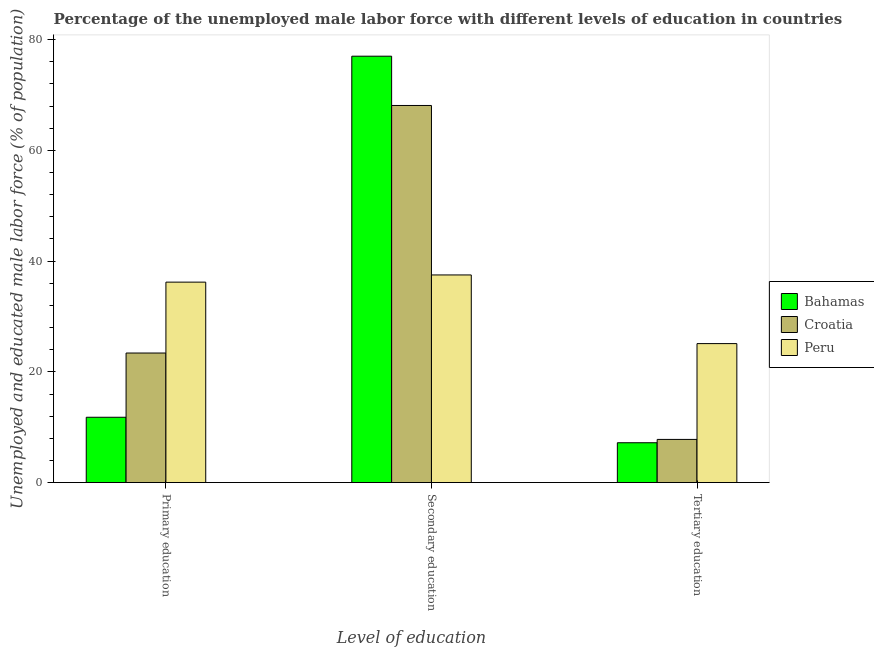Are the number of bars on each tick of the X-axis equal?
Give a very brief answer. Yes. How many bars are there on the 2nd tick from the left?
Keep it short and to the point. 3. What is the label of the 2nd group of bars from the left?
Provide a succinct answer. Secondary education. What is the percentage of male labor force who received tertiary education in Bahamas?
Keep it short and to the point. 7.2. Across all countries, what is the maximum percentage of male labor force who received tertiary education?
Your answer should be compact. 25.1. Across all countries, what is the minimum percentage of male labor force who received secondary education?
Your response must be concise. 37.5. In which country was the percentage of male labor force who received tertiary education maximum?
Your answer should be very brief. Peru. What is the total percentage of male labor force who received secondary education in the graph?
Your answer should be very brief. 182.6. What is the difference between the percentage of male labor force who received tertiary education in Croatia and that in Bahamas?
Keep it short and to the point. 0.6. What is the difference between the percentage of male labor force who received primary education in Croatia and the percentage of male labor force who received secondary education in Peru?
Give a very brief answer. -14.1. What is the average percentage of male labor force who received tertiary education per country?
Provide a succinct answer. 13.37. What is the difference between the percentage of male labor force who received tertiary education and percentage of male labor force who received primary education in Croatia?
Ensure brevity in your answer.  -15.6. In how many countries, is the percentage of male labor force who received tertiary education greater than 4 %?
Offer a very short reply. 3. What is the ratio of the percentage of male labor force who received secondary education in Bahamas to that in Croatia?
Provide a succinct answer. 1.13. Is the difference between the percentage of male labor force who received tertiary education in Peru and Croatia greater than the difference between the percentage of male labor force who received primary education in Peru and Croatia?
Your answer should be compact. Yes. What is the difference between the highest and the second highest percentage of male labor force who received tertiary education?
Provide a succinct answer. 17.3. What is the difference between the highest and the lowest percentage of male labor force who received primary education?
Your response must be concise. 24.4. In how many countries, is the percentage of male labor force who received secondary education greater than the average percentage of male labor force who received secondary education taken over all countries?
Ensure brevity in your answer.  2. What does the 2nd bar from the left in Tertiary education represents?
Make the answer very short. Croatia. What does the 3rd bar from the right in Tertiary education represents?
Your answer should be compact. Bahamas. Is it the case that in every country, the sum of the percentage of male labor force who received primary education and percentage of male labor force who received secondary education is greater than the percentage of male labor force who received tertiary education?
Ensure brevity in your answer.  Yes. How many bars are there?
Ensure brevity in your answer.  9. Are all the bars in the graph horizontal?
Your answer should be compact. No. How many countries are there in the graph?
Make the answer very short. 3. What is the difference between two consecutive major ticks on the Y-axis?
Keep it short and to the point. 20. Are the values on the major ticks of Y-axis written in scientific E-notation?
Your answer should be compact. No. Does the graph contain any zero values?
Provide a succinct answer. No. Does the graph contain grids?
Your answer should be compact. No. How are the legend labels stacked?
Offer a terse response. Vertical. What is the title of the graph?
Make the answer very short. Percentage of the unemployed male labor force with different levels of education in countries. Does "Mauritius" appear as one of the legend labels in the graph?
Offer a very short reply. No. What is the label or title of the X-axis?
Make the answer very short. Level of education. What is the label or title of the Y-axis?
Provide a short and direct response. Unemployed and educated male labor force (% of population). What is the Unemployed and educated male labor force (% of population) of Bahamas in Primary education?
Your answer should be very brief. 11.8. What is the Unemployed and educated male labor force (% of population) of Croatia in Primary education?
Ensure brevity in your answer.  23.4. What is the Unemployed and educated male labor force (% of population) in Peru in Primary education?
Provide a short and direct response. 36.2. What is the Unemployed and educated male labor force (% of population) in Bahamas in Secondary education?
Give a very brief answer. 77. What is the Unemployed and educated male labor force (% of population) of Croatia in Secondary education?
Provide a succinct answer. 68.1. What is the Unemployed and educated male labor force (% of population) in Peru in Secondary education?
Offer a terse response. 37.5. What is the Unemployed and educated male labor force (% of population) of Bahamas in Tertiary education?
Your answer should be compact. 7.2. What is the Unemployed and educated male labor force (% of population) of Croatia in Tertiary education?
Ensure brevity in your answer.  7.8. What is the Unemployed and educated male labor force (% of population) of Peru in Tertiary education?
Give a very brief answer. 25.1. Across all Level of education, what is the maximum Unemployed and educated male labor force (% of population) of Bahamas?
Your answer should be very brief. 77. Across all Level of education, what is the maximum Unemployed and educated male labor force (% of population) in Croatia?
Make the answer very short. 68.1. Across all Level of education, what is the maximum Unemployed and educated male labor force (% of population) of Peru?
Offer a very short reply. 37.5. Across all Level of education, what is the minimum Unemployed and educated male labor force (% of population) of Bahamas?
Give a very brief answer. 7.2. Across all Level of education, what is the minimum Unemployed and educated male labor force (% of population) in Croatia?
Ensure brevity in your answer.  7.8. Across all Level of education, what is the minimum Unemployed and educated male labor force (% of population) of Peru?
Give a very brief answer. 25.1. What is the total Unemployed and educated male labor force (% of population) in Bahamas in the graph?
Ensure brevity in your answer.  96. What is the total Unemployed and educated male labor force (% of population) of Croatia in the graph?
Give a very brief answer. 99.3. What is the total Unemployed and educated male labor force (% of population) of Peru in the graph?
Offer a terse response. 98.8. What is the difference between the Unemployed and educated male labor force (% of population) of Bahamas in Primary education and that in Secondary education?
Your answer should be very brief. -65.2. What is the difference between the Unemployed and educated male labor force (% of population) in Croatia in Primary education and that in Secondary education?
Provide a short and direct response. -44.7. What is the difference between the Unemployed and educated male labor force (% of population) of Peru in Primary education and that in Secondary education?
Your answer should be very brief. -1.3. What is the difference between the Unemployed and educated male labor force (% of population) of Croatia in Primary education and that in Tertiary education?
Your response must be concise. 15.6. What is the difference between the Unemployed and educated male labor force (% of population) in Peru in Primary education and that in Tertiary education?
Your response must be concise. 11.1. What is the difference between the Unemployed and educated male labor force (% of population) of Bahamas in Secondary education and that in Tertiary education?
Ensure brevity in your answer.  69.8. What is the difference between the Unemployed and educated male labor force (% of population) of Croatia in Secondary education and that in Tertiary education?
Make the answer very short. 60.3. What is the difference between the Unemployed and educated male labor force (% of population) of Bahamas in Primary education and the Unemployed and educated male labor force (% of population) of Croatia in Secondary education?
Keep it short and to the point. -56.3. What is the difference between the Unemployed and educated male labor force (% of population) in Bahamas in Primary education and the Unemployed and educated male labor force (% of population) in Peru in Secondary education?
Offer a very short reply. -25.7. What is the difference between the Unemployed and educated male labor force (% of population) of Croatia in Primary education and the Unemployed and educated male labor force (% of population) of Peru in Secondary education?
Your answer should be very brief. -14.1. What is the difference between the Unemployed and educated male labor force (% of population) in Bahamas in Primary education and the Unemployed and educated male labor force (% of population) in Croatia in Tertiary education?
Provide a short and direct response. 4. What is the difference between the Unemployed and educated male labor force (% of population) in Bahamas in Primary education and the Unemployed and educated male labor force (% of population) in Peru in Tertiary education?
Your answer should be compact. -13.3. What is the difference between the Unemployed and educated male labor force (% of population) in Croatia in Primary education and the Unemployed and educated male labor force (% of population) in Peru in Tertiary education?
Offer a terse response. -1.7. What is the difference between the Unemployed and educated male labor force (% of population) in Bahamas in Secondary education and the Unemployed and educated male labor force (% of population) in Croatia in Tertiary education?
Keep it short and to the point. 69.2. What is the difference between the Unemployed and educated male labor force (% of population) in Bahamas in Secondary education and the Unemployed and educated male labor force (% of population) in Peru in Tertiary education?
Keep it short and to the point. 51.9. What is the difference between the Unemployed and educated male labor force (% of population) in Croatia in Secondary education and the Unemployed and educated male labor force (% of population) in Peru in Tertiary education?
Your response must be concise. 43. What is the average Unemployed and educated male labor force (% of population) of Bahamas per Level of education?
Your response must be concise. 32. What is the average Unemployed and educated male labor force (% of population) of Croatia per Level of education?
Offer a very short reply. 33.1. What is the average Unemployed and educated male labor force (% of population) of Peru per Level of education?
Your answer should be very brief. 32.93. What is the difference between the Unemployed and educated male labor force (% of population) in Bahamas and Unemployed and educated male labor force (% of population) in Croatia in Primary education?
Ensure brevity in your answer.  -11.6. What is the difference between the Unemployed and educated male labor force (% of population) of Bahamas and Unemployed and educated male labor force (% of population) of Peru in Primary education?
Keep it short and to the point. -24.4. What is the difference between the Unemployed and educated male labor force (% of population) of Bahamas and Unemployed and educated male labor force (% of population) of Croatia in Secondary education?
Offer a terse response. 8.9. What is the difference between the Unemployed and educated male labor force (% of population) of Bahamas and Unemployed and educated male labor force (% of population) of Peru in Secondary education?
Give a very brief answer. 39.5. What is the difference between the Unemployed and educated male labor force (% of population) of Croatia and Unemployed and educated male labor force (% of population) of Peru in Secondary education?
Offer a terse response. 30.6. What is the difference between the Unemployed and educated male labor force (% of population) of Bahamas and Unemployed and educated male labor force (% of population) of Croatia in Tertiary education?
Make the answer very short. -0.6. What is the difference between the Unemployed and educated male labor force (% of population) of Bahamas and Unemployed and educated male labor force (% of population) of Peru in Tertiary education?
Your answer should be very brief. -17.9. What is the difference between the Unemployed and educated male labor force (% of population) in Croatia and Unemployed and educated male labor force (% of population) in Peru in Tertiary education?
Offer a very short reply. -17.3. What is the ratio of the Unemployed and educated male labor force (% of population) in Bahamas in Primary education to that in Secondary education?
Provide a short and direct response. 0.15. What is the ratio of the Unemployed and educated male labor force (% of population) of Croatia in Primary education to that in Secondary education?
Make the answer very short. 0.34. What is the ratio of the Unemployed and educated male labor force (% of population) in Peru in Primary education to that in Secondary education?
Offer a terse response. 0.97. What is the ratio of the Unemployed and educated male labor force (% of population) in Bahamas in Primary education to that in Tertiary education?
Your answer should be very brief. 1.64. What is the ratio of the Unemployed and educated male labor force (% of population) of Croatia in Primary education to that in Tertiary education?
Keep it short and to the point. 3. What is the ratio of the Unemployed and educated male labor force (% of population) in Peru in Primary education to that in Tertiary education?
Give a very brief answer. 1.44. What is the ratio of the Unemployed and educated male labor force (% of population) of Bahamas in Secondary education to that in Tertiary education?
Provide a short and direct response. 10.69. What is the ratio of the Unemployed and educated male labor force (% of population) of Croatia in Secondary education to that in Tertiary education?
Keep it short and to the point. 8.73. What is the ratio of the Unemployed and educated male labor force (% of population) in Peru in Secondary education to that in Tertiary education?
Your answer should be very brief. 1.49. What is the difference between the highest and the second highest Unemployed and educated male labor force (% of population) of Bahamas?
Keep it short and to the point. 65.2. What is the difference between the highest and the second highest Unemployed and educated male labor force (% of population) in Croatia?
Provide a succinct answer. 44.7. What is the difference between the highest and the second highest Unemployed and educated male labor force (% of population) in Peru?
Offer a very short reply. 1.3. What is the difference between the highest and the lowest Unemployed and educated male labor force (% of population) in Bahamas?
Keep it short and to the point. 69.8. What is the difference between the highest and the lowest Unemployed and educated male labor force (% of population) in Croatia?
Make the answer very short. 60.3. What is the difference between the highest and the lowest Unemployed and educated male labor force (% of population) in Peru?
Give a very brief answer. 12.4. 